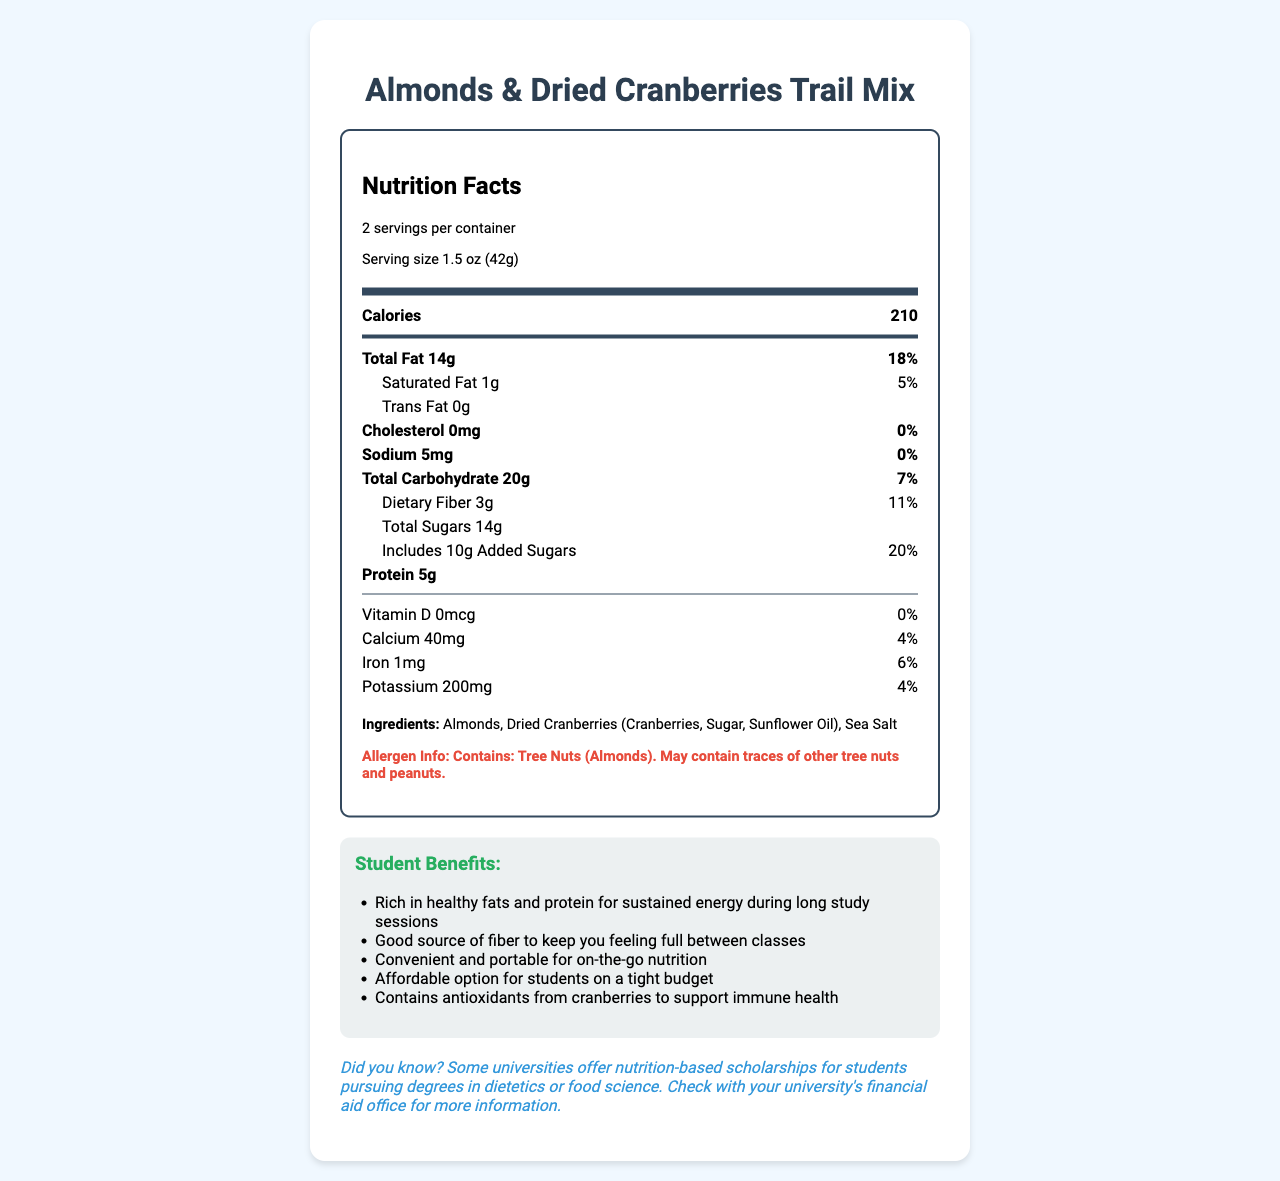what is the product name? The product name is displayed at the top of the label.
Answer: Almonds & Dried Cranberries Trail Mix how many calories are in a serving? The number of calories per serving is listed in the nutrient row under "Calories."
Answer: 210 how much dietary fiber is there per serving? The amount of dietary fiber is listed under the "Total Carbohydrate" section.
Answer: 3 grams what is the serving size and how many servings per container? The serving size and servings per container are indicated in the serving information at the top of the label.
Answer: 1.5 oz (42g), 2 servings per container list the ingredients of the product. The ingredients are listed in the ingredients section toward the bottom of the label.
Answer: Almonds, Dried Cranberries (Cranberries, Sugar, Sunflower Oil), Sea Salt which nutrient has a % Daily Value of 20%? A. Total Fat B. Saturated Fat C. Added Sugars D. Vitamin D The % Daily Value for Added Sugars is 20%, as listed in the "Includes Added Sugars" row.
Answer: C. Added Sugars what is the % Daily Value of Iron in this product? A. 4% B. 5% C. 6% D. 7% The % Daily Value for Iron is 6%, as listed in the nutrient row for iron.
Answer: C. 6% does this product contain any cholesterol? The cholesterol content is listed as 0 milligrams with a 0% Daily Value.
Answer: No is this product high in sodium? The sodium content is 5 milligrams, which is 0% of the Daily Value, indicating that it is not high in sodium.
Answer: No summarize the student benefits of this product. The benefits are listed in the "Student Benefits" section and include points about energy, fiber, convenience, cost, and antioxidants.
Answer: This product offers sustained energy, fullness between classes, portability, affordability for students on a budget, and antioxidants to support immune health. what is the manufacturer of this trail mix? The manufacturer is listed at the bottom of the label.
Answer: Campus Snacks Co. who should avoid this product based on allergen information? The allergen information specifies that the product contains tree nuts (almonds) and may contain traces of other tree nuts and peanuts.
Answer: Individuals allergic to tree nuts or peanuts should avoid this product. how should this product be stored? The storage instructions are stated at the bottom of the label.
Answer: Store in a cool, dry place. what is the potassium content per serving? The potassium content is listed in the nutrient row toward the bottom of the label.
Answer: 200 milligrams does the product contain Vitamin D? The Vitamin D content is listed as 0 micrograms with a 0% Daily Value.
Answer: No can the % Daily Value of nutrients be determined for this product? The % Daily Values for various nutrients are provided next to their respective nutrient names in the nutrient rows.
Answer: Yes how many grams of total sugars are there per serving? The total sugars per serving are listed under the "Total Sugars" row.
Answer: 14 grams are there any universities offering scholarships mentioned in the document? The document mentions that some universities offer nutrition-based scholarships for students pursuing degrees in dietetics or food science.
Answer: Yes what are the individual items within the dried cranberries ingredient? The breakdown of dried cranberries' ingredients is given in parentheses in the ingredients list.
Answer: Cranberries, Sugar, Sunflower Oil 